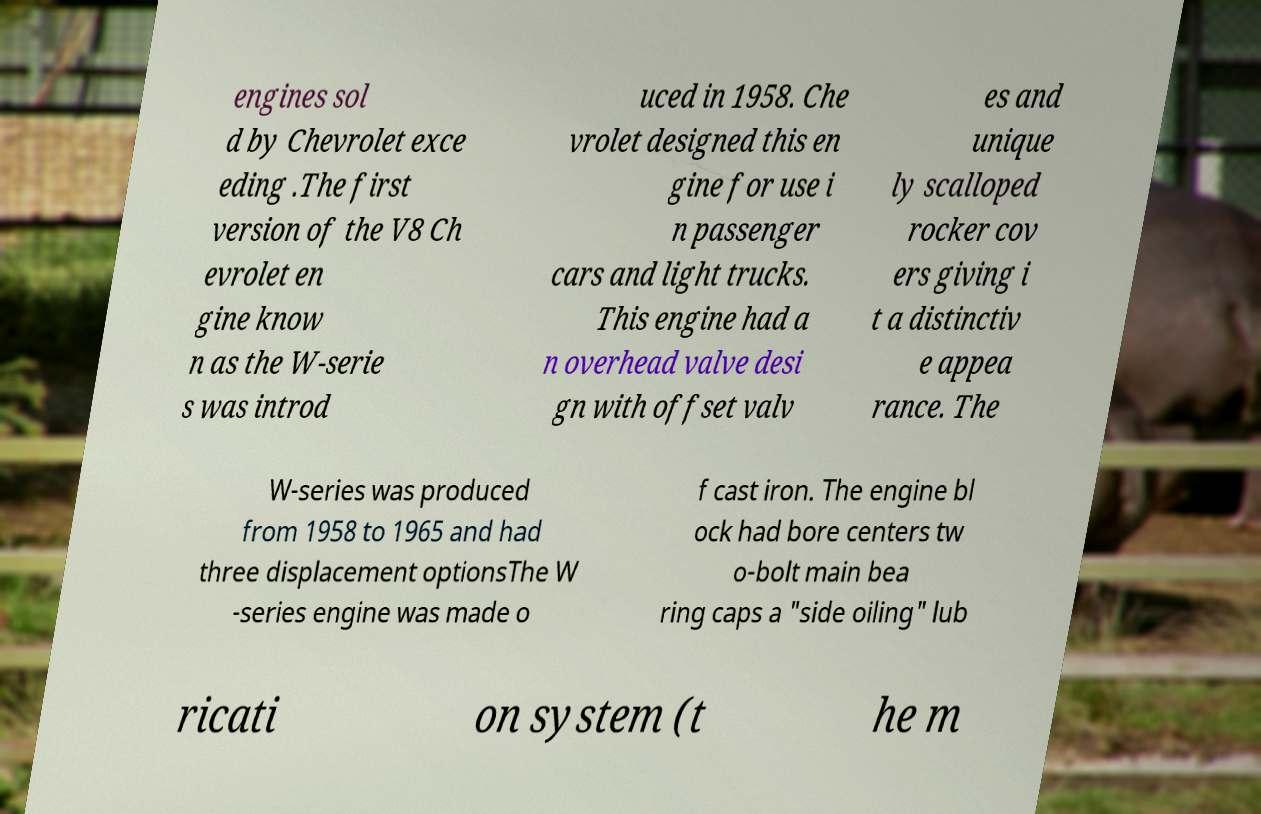Can you accurately transcribe the text from the provided image for me? engines sol d by Chevrolet exce eding .The first version of the V8 Ch evrolet en gine know n as the W-serie s was introd uced in 1958. Che vrolet designed this en gine for use i n passenger cars and light trucks. This engine had a n overhead valve desi gn with offset valv es and unique ly scalloped rocker cov ers giving i t a distinctiv e appea rance. The W-series was produced from 1958 to 1965 and had three displacement optionsThe W -series engine was made o f cast iron. The engine bl ock had bore centers tw o-bolt main bea ring caps a "side oiling" lub ricati on system (t he m 